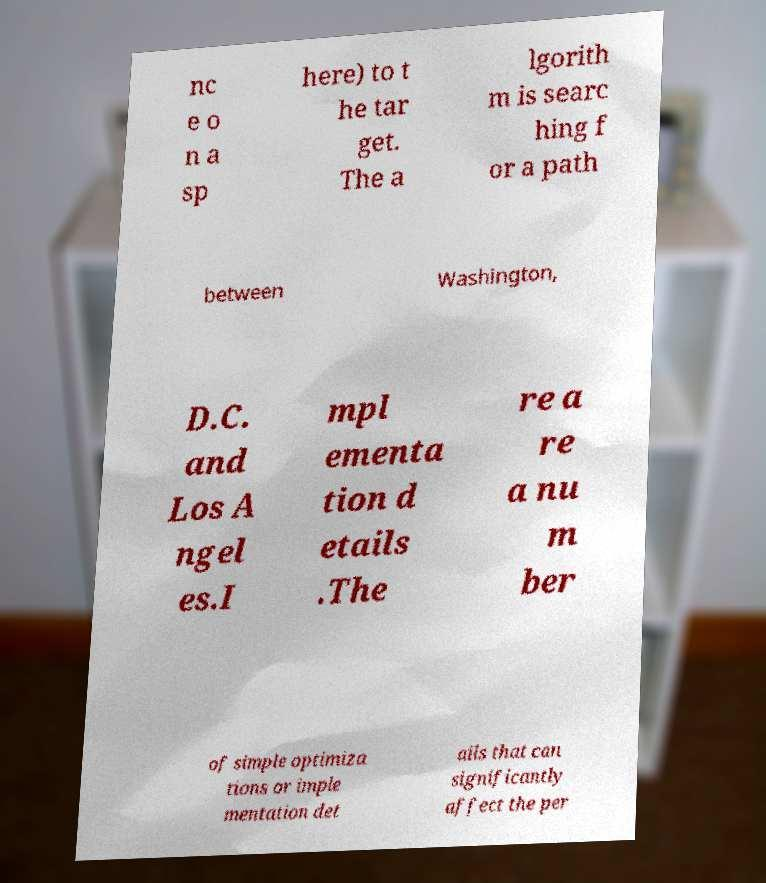Can you accurately transcribe the text from the provided image for me? nc e o n a sp here) to t he tar get. The a lgorith m is searc hing f or a path between Washington, D.C. and Los A ngel es.I mpl ementa tion d etails .The re a re a nu m ber of simple optimiza tions or imple mentation det ails that can significantly affect the per 